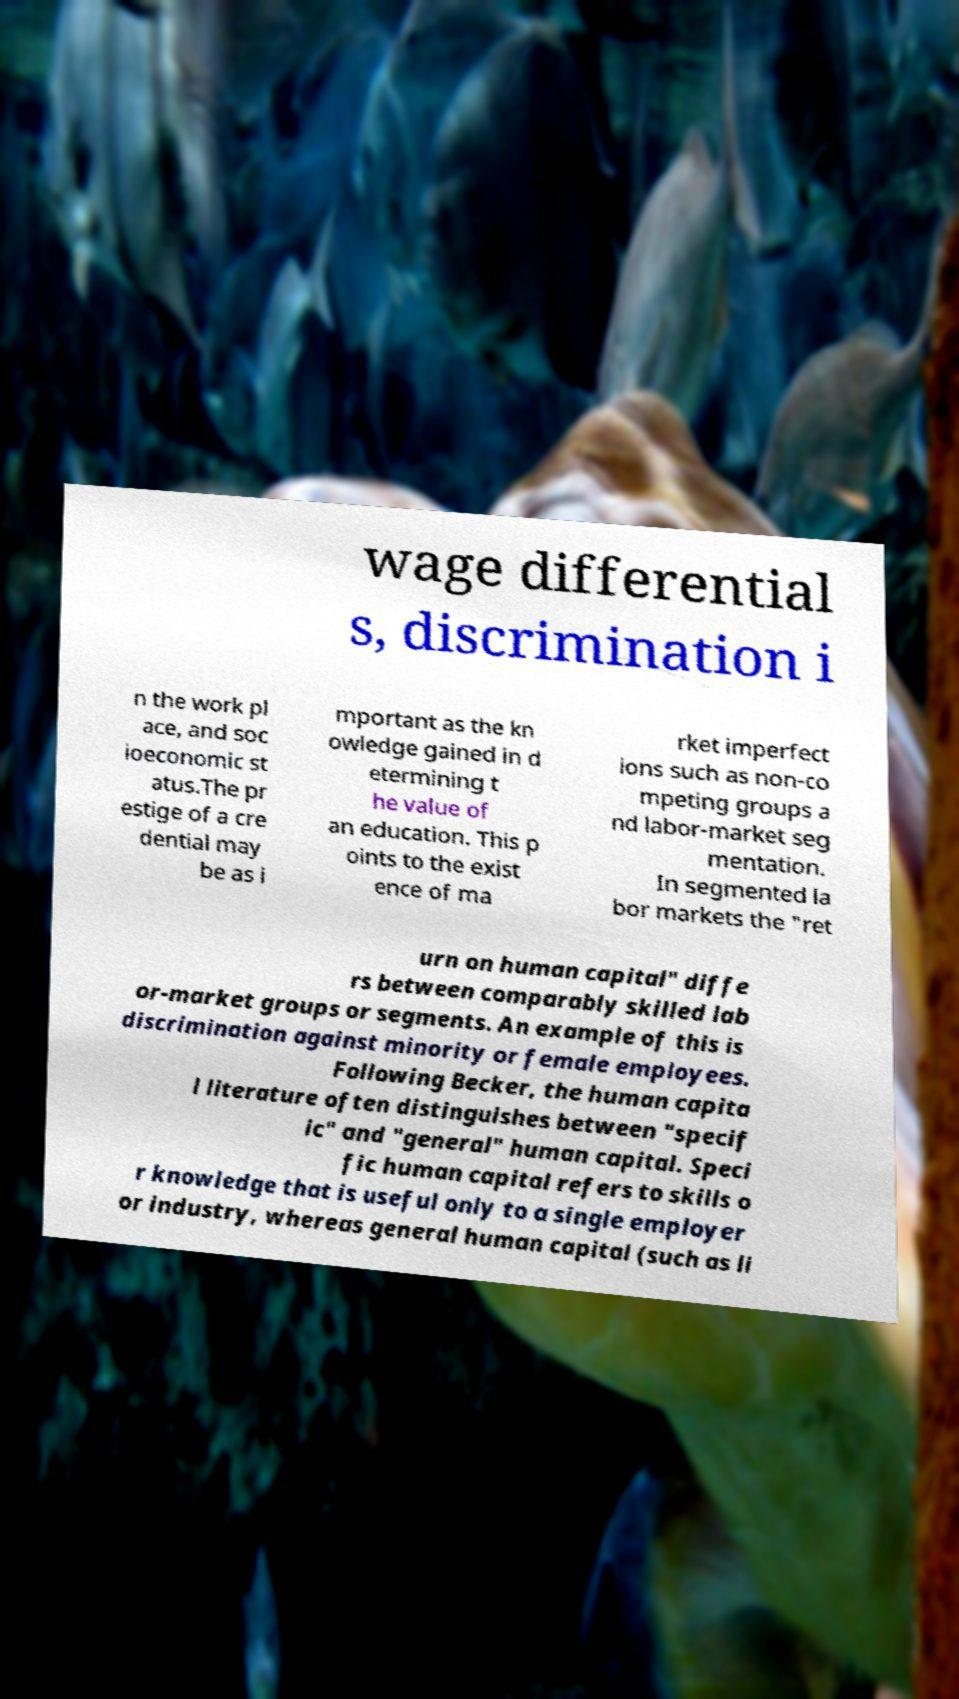Please read and relay the text visible in this image. What does it say? wage differential s, discrimination i n the work pl ace, and soc ioeconomic st atus.The pr estige of a cre dential may be as i mportant as the kn owledge gained in d etermining t he value of an education. This p oints to the exist ence of ma rket imperfect ions such as non-co mpeting groups a nd labor-market seg mentation. In segmented la bor markets the "ret urn on human capital" diffe rs between comparably skilled lab or-market groups or segments. An example of this is discrimination against minority or female employees. Following Becker, the human capita l literature often distinguishes between "specif ic" and "general" human capital. Speci fic human capital refers to skills o r knowledge that is useful only to a single employer or industry, whereas general human capital (such as li 